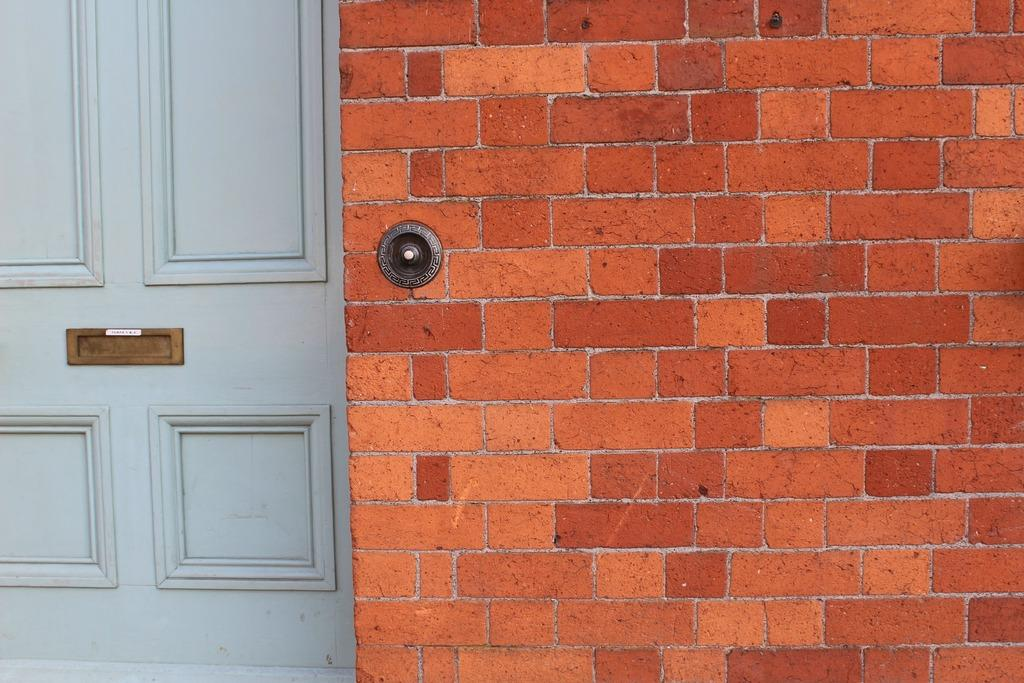What type of structure can be seen in the image? There is a wall in the image. Is there any entrance visible in the image? Yes, there is a door in the image. What is attached to the wall in the image? There is an object attached to the wall in the image. What country is the wall from in the image? The facts provided do not mention any specific country, so it cannot be determined from the image. 